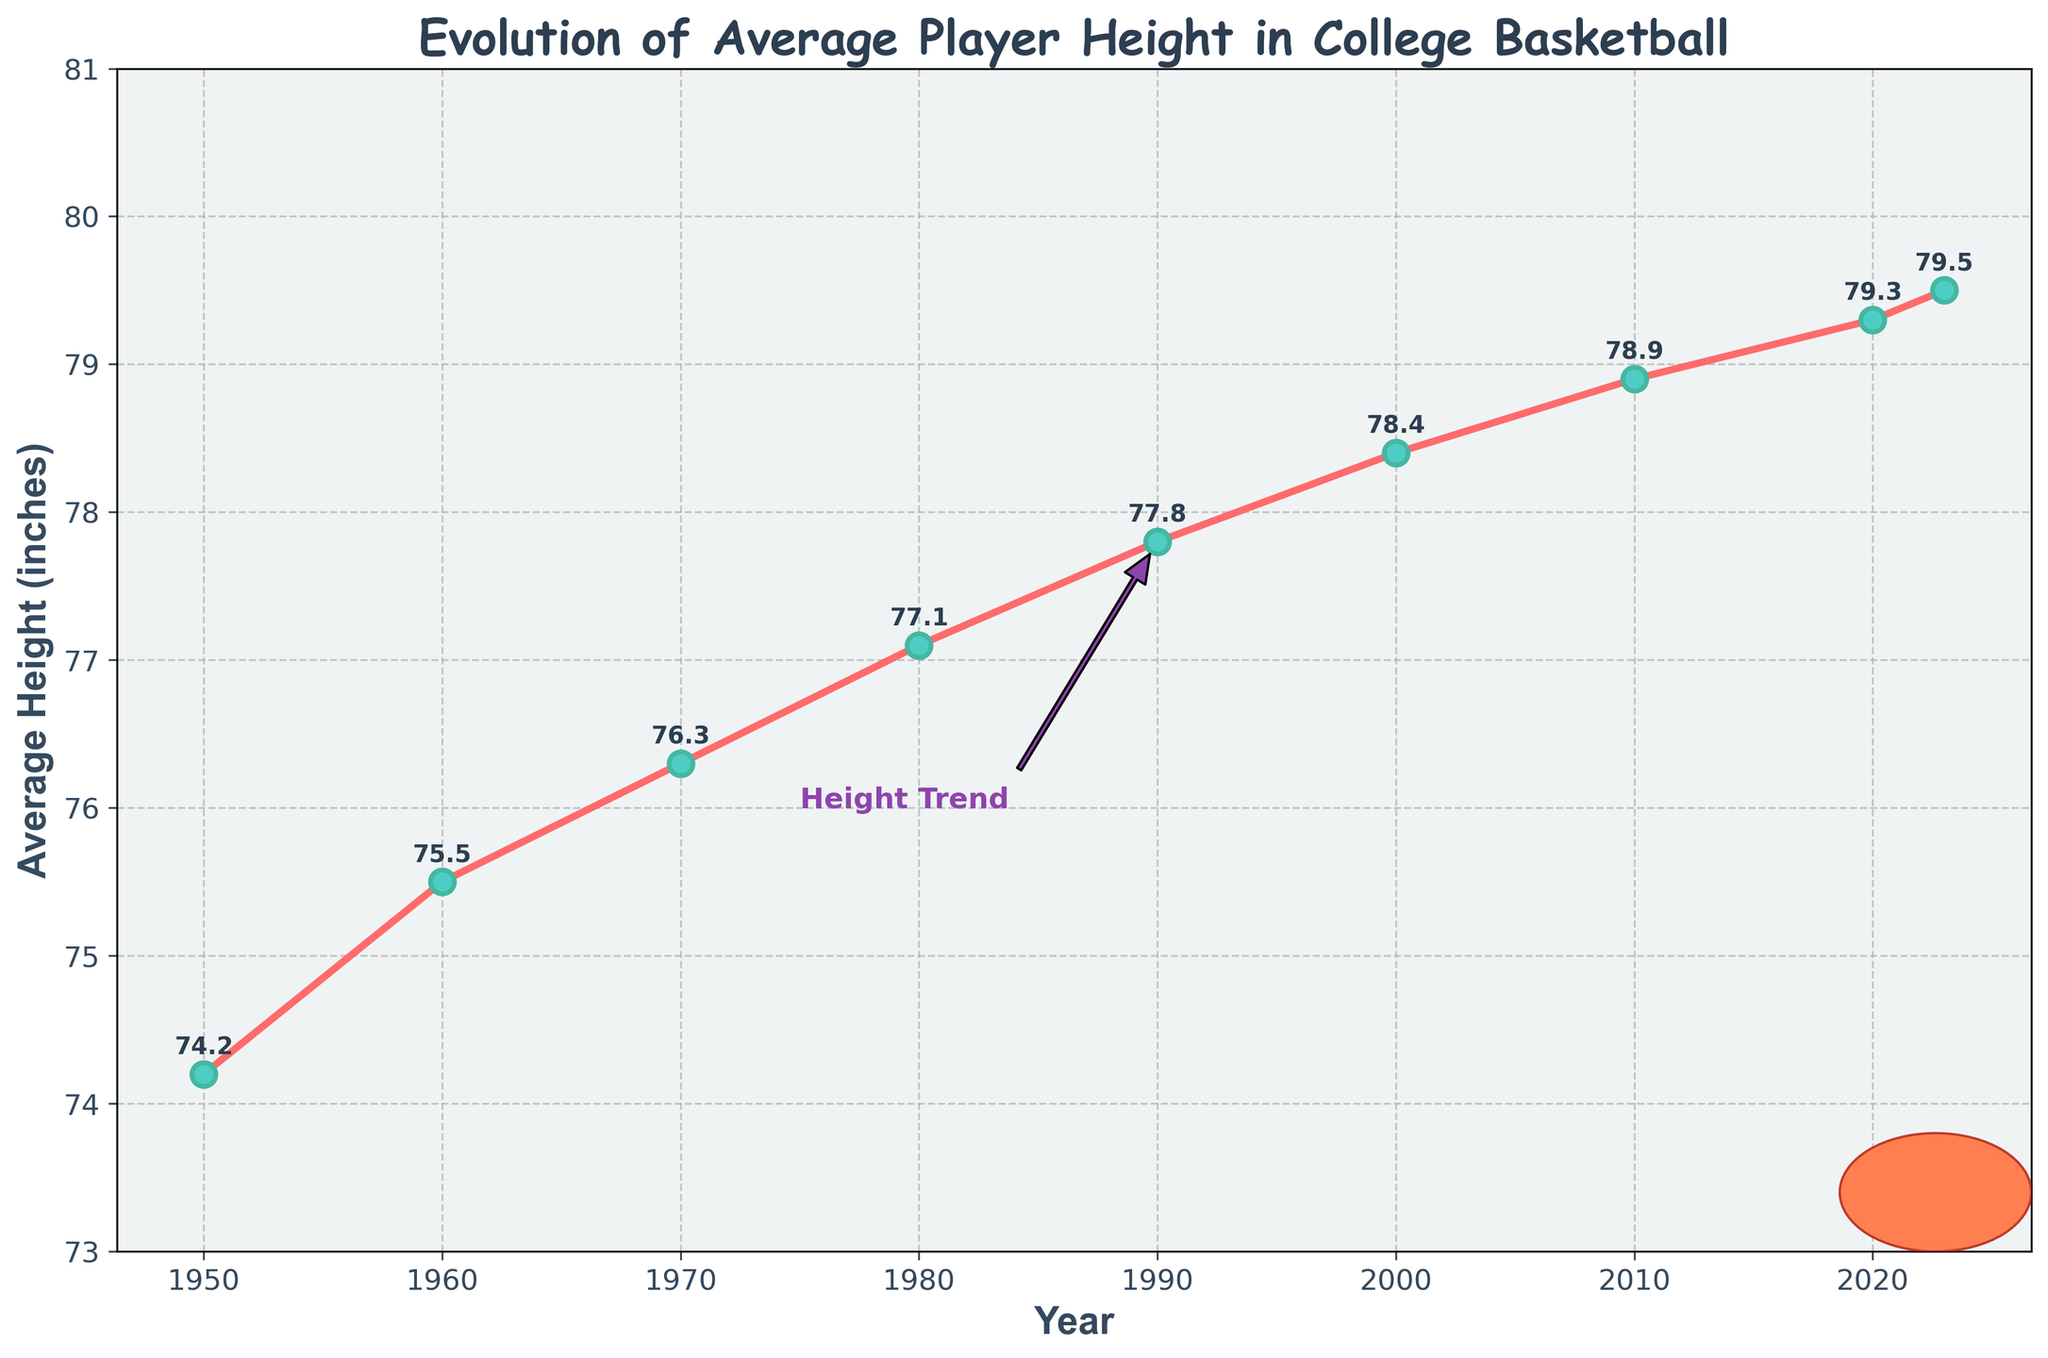What's the average height of players in the 1950s and 1960s combined? To find the average height for these decades, sum the average heights of 1950 and 1960, then divide by 2. The heights are 74.2 and 75.5 inches respectively. (74.2 + 75.5) / 2 = 149.7 / 2 = 74.85 inches
Answer: 74.85 inches Between which two decades did the average player height increase the most? Calculate the differences in average height between each consecutive decade and find the largest difference. The differences are: 60s-50s: 75.5-74.2=1.3, 70s-60s: 76.3-75.5=0.8, 80s-70s: 77.1-76.3=0.8, 90s-80s: 77.8-77.1=0.7, 00s-90s: 78.4-77.8=0.6, 10s-00s: 78.9-78.4=0.5, 20s-10s: 79.3-78.9=0.4. The largest increase is between the 1950s and 1960s, which is 1.3 inches
Answer: Between the 1950s and 1960s Which year had the smallest increase in average height compared to the previous decade? Compare the increase in average height for each decade. By subtracting the previous decade's average from each decade: 60s-50s: 1.3, 70s-60s: 0.8, 80s-70s: 0.8, 90s-80s: 0.7, 00s-90s: 0.6, 10s-00s: 0.5, 20s-10s: 0.4. The smallest increase occurs between 2010 and 2020, which is 0.4 inches
Answer: 2020 What's the trend in players' average heights over time? Observe the overall pattern of the line in the plot. The average height consistently increases over the years from 1950 to 2023. The line goes upward throughout the entire period
Answer: The trend is an increase By how much did the average height increase from 1950 to 2020? Subtract the average height in 1950 from that in 2020: 79.3 - 74.2 = 5.1 inches
Answer: 5.1 inches Identify two years in which the average height is closest to 78 inches. Examine the data points on the plot that are nearest to 78 inches. In the dataset, the years are 2000 (78.4 inches) and 2010 (78.9 inches), which are the closest heights to 78 inches
Answer: 2000 and 2010 